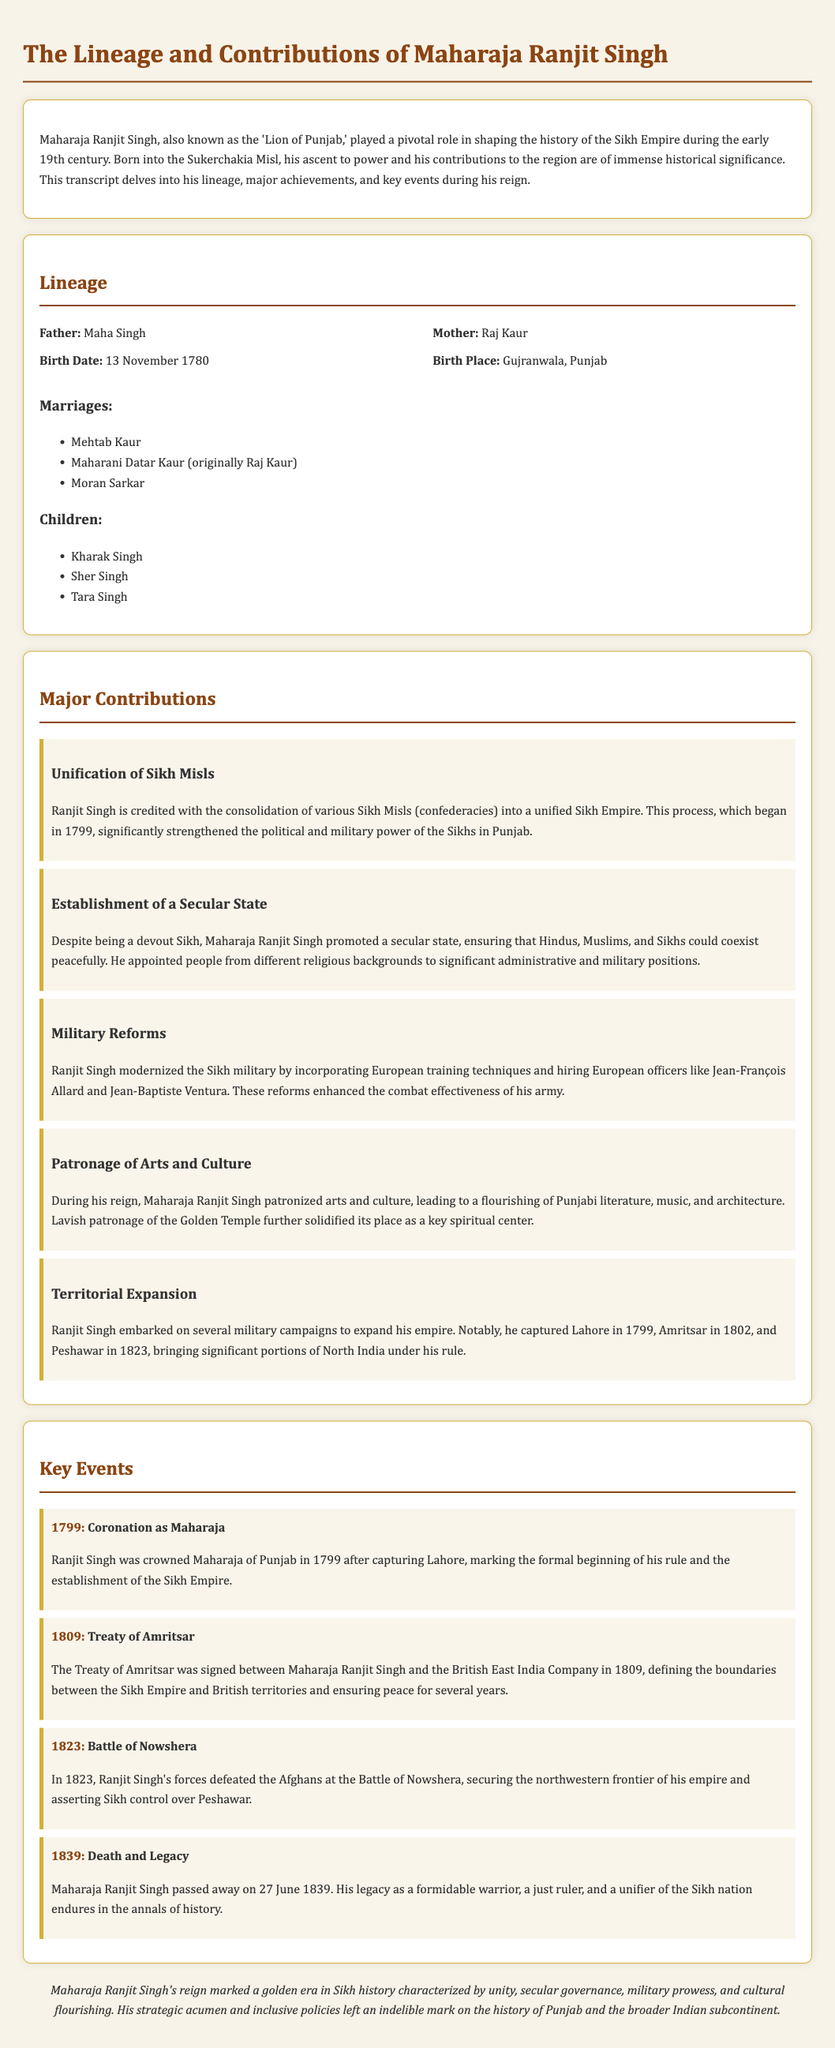What is the birth date of Maharaja Ranjit Singh? The document states that Maharaja Ranjit Singh was born on 13 November 1780.
Answer: 13 November 1780 Who was the father of Maharaja Ranjit Singh? The document lists Maha Singh as the father of Maharaja Ranjit Singh.
Answer: Maha Singh What significant event occurred in 1799? In 1799, Ranjit Singh was crowned Maharaja of Punjab, marking the establishment of the Sikh Empire.
Answer: Coronation as Maharaja Which treaty was signed in 1809? The document mentions the Treaty of Amritsar was signed between Maharaja Ranjit Singh and the British East India Company in 1809.
Answer: Treaty of Amritsar What was one of Maharaja Ranjit Singh's major contributions to the Sikh Empire? The document highlights his contribution to the unification of Sikh Misls into a unified Sikh Empire.
Answer: Unification of Sikh Misls What was the year of the Battle of Nowshera? According to the document, the Battle of Nowshera occurred in 1823.
Answer: 1823 How many children did Maharaja Ranjit Singh have listed in the document? The document lists three children: Kharak Singh, Sher Singh, and Tara Singh.
Answer: Three What notable military reform did Ranjit Singh implement? The document states that Ranjit Singh modernized the Sikh military by incorporating European training techniques.
Answer: Military Reforms 